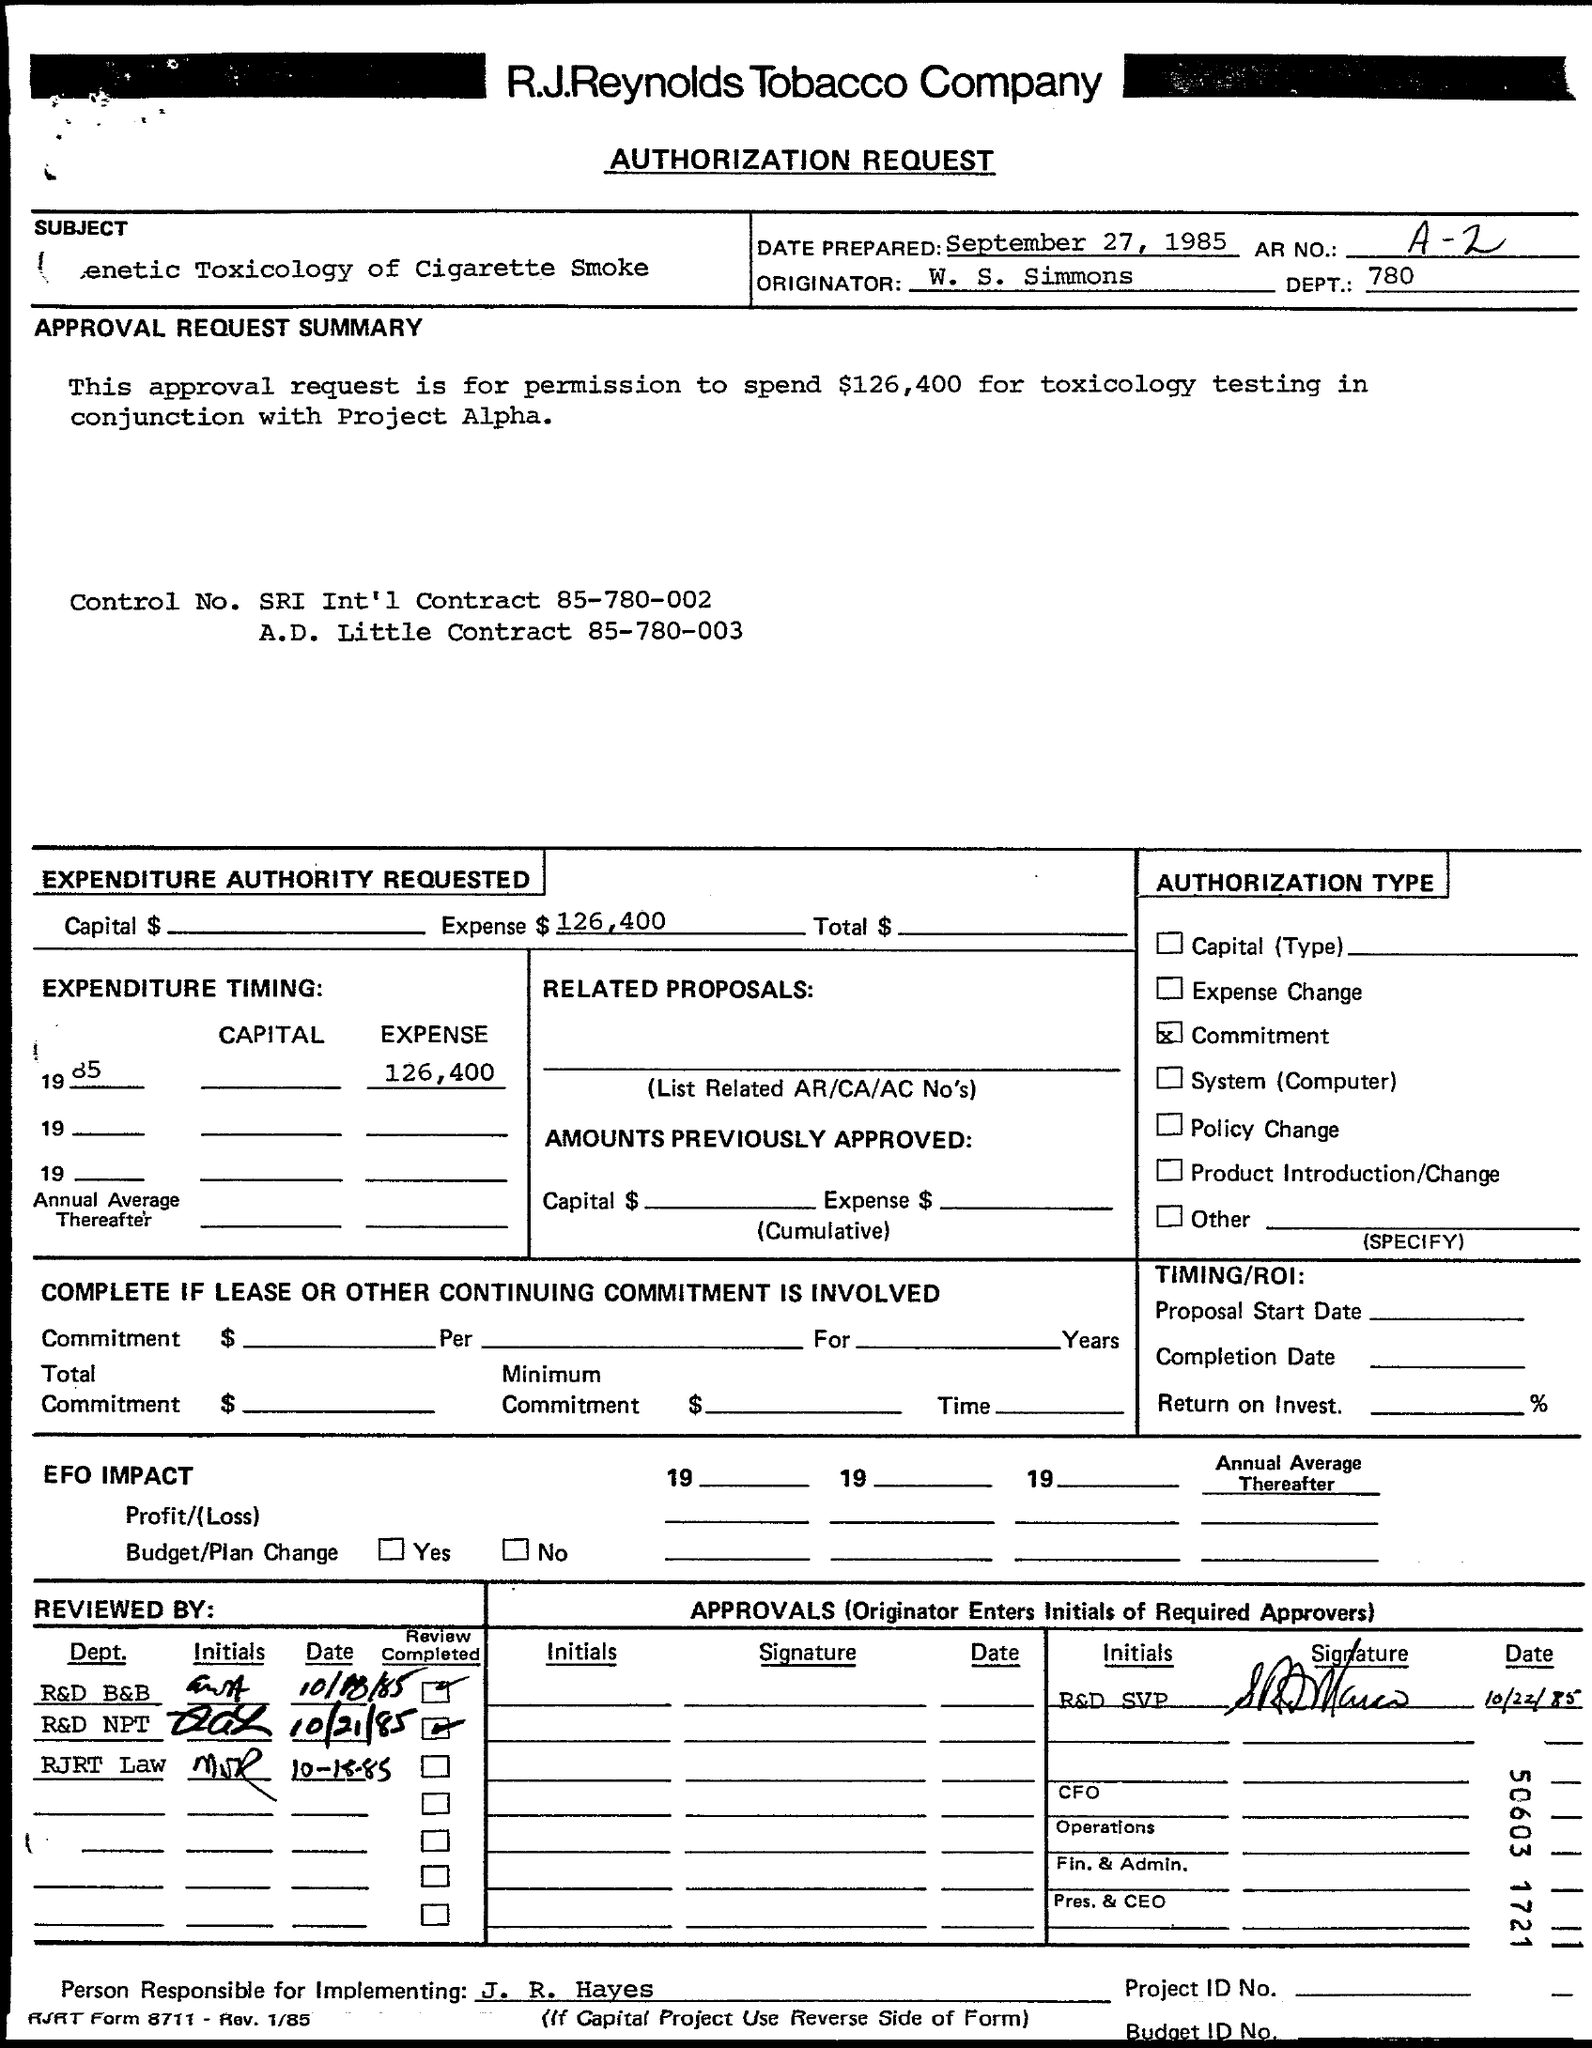What's AR NO?
Provide a succinct answer. A-2. 